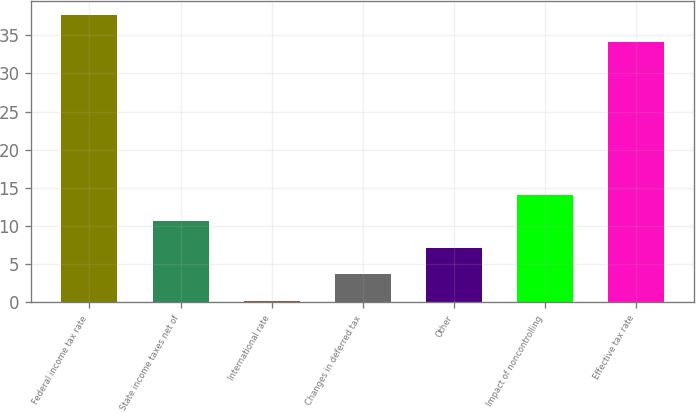<chart> <loc_0><loc_0><loc_500><loc_500><bar_chart><fcel>Federal income tax rate<fcel>State income taxes net of<fcel>International rate<fcel>Changes in deferred tax<fcel>Other<fcel>Impact of noncontrolling<fcel>Effective tax rate<nl><fcel>37.58<fcel>10.64<fcel>0.2<fcel>3.68<fcel>7.16<fcel>14.12<fcel>34.1<nl></chart> 